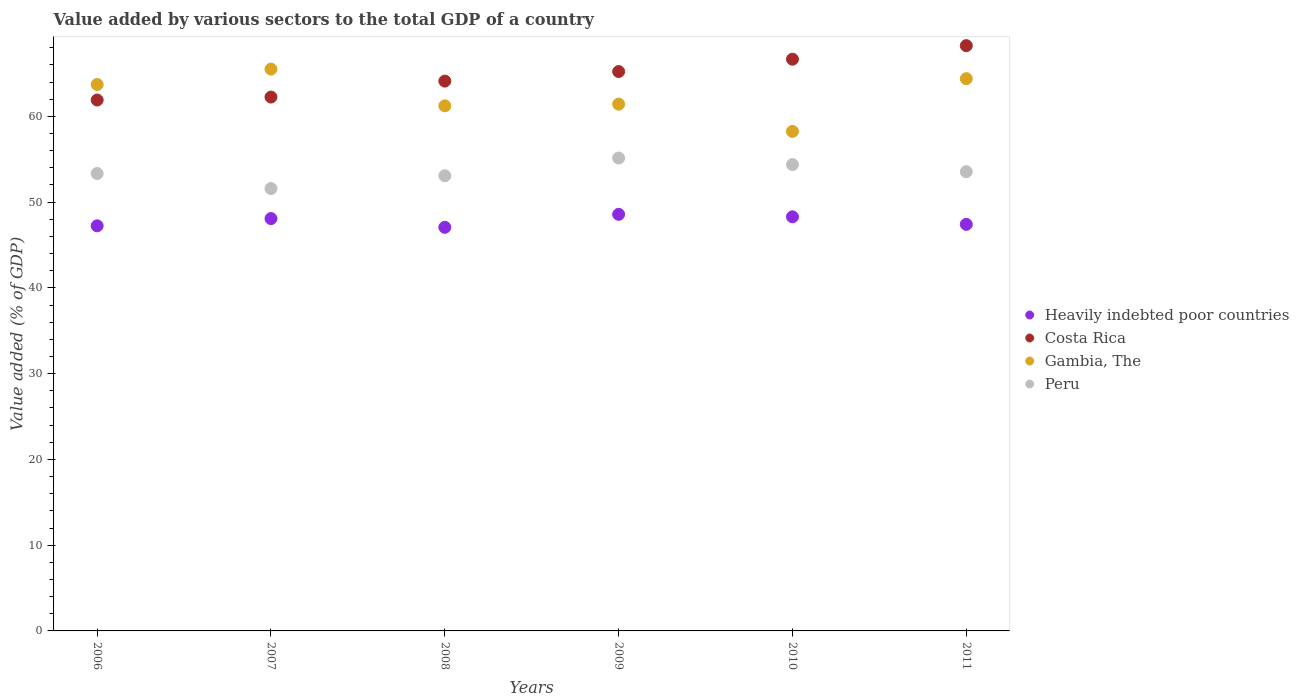Is the number of dotlines equal to the number of legend labels?
Offer a terse response. Yes. What is the value added by various sectors to the total GDP in Gambia, The in 2007?
Your answer should be very brief. 65.51. Across all years, what is the maximum value added by various sectors to the total GDP in Gambia, The?
Your response must be concise. 65.51. Across all years, what is the minimum value added by various sectors to the total GDP in Gambia, The?
Keep it short and to the point. 58.25. In which year was the value added by various sectors to the total GDP in Heavily indebted poor countries minimum?
Your response must be concise. 2008. What is the total value added by various sectors to the total GDP in Heavily indebted poor countries in the graph?
Give a very brief answer. 286.65. What is the difference between the value added by various sectors to the total GDP in Heavily indebted poor countries in 2006 and that in 2011?
Your answer should be compact. -0.17. What is the difference between the value added by various sectors to the total GDP in Gambia, The in 2010 and the value added by various sectors to the total GDP in Costa Rica in 2009?
Give a very brief answer. -6.98. What is the average value added by various sectors to the total GDP in Gambia, The per year?
Your answer should be very brief. 62.42. In the year 2009, what is the difference between the value added by various sectors to the total GDP in Heavily indebted poor countries and value added by various sectors to the total GDP in Costa Rica?
Provide a short and direct response. -16.65. In how many years, is the value added by various sectors to the total GDP in Heavily indebted poor countries greater than 16 %?
Offer a terse response. 6. What is the ratio of the value added by various sectors to the total GDP in Heavily indebted poor countries in 2006 to that in 2008?
Provide a succinct answer. 1. Is the value added by various sectors to the total GDP in Peru in 2009 less than that in 2010?
Keep it short and to the point. No. What is the difference between the highest and the second highest value added by various sectors to the total GDP in Gambia, The?
Ensure brevity in your answer.  1.12. What is the difference between the highest and the lowest value added by various sectors to the total GDP in Gambia, The?
Provide a succinct answer. 7.27. In how many years, is the value added by various sectors to the total GDP in Peru greater than the average value added by various sectors to the total GDP in Peru taken over all years?
Give a very brief answer. 3. Is the value added by various sectors to the total GDP in Gambia, The strictly less than the value added by various sectors to the total GDP in Peru over the years?
Your answer should be very brief. No. How many dotlines are there?
Give a very brief answer. 4. How many years are there in the graph?
Your answer should be very brief. 6. Does the graph contain any zero values?
Your answer should be very brief. No. Where does the legend appear in the graph?
Make the answer very short. Center right. How many legend labels are there?
Provide a short and direct response. 4. What is the title of the graph?
Offer a terse response. Value added by various sectors to the total GDP of a country. What is the label or title of the Y-axis?
Your response must be concise. Value added (% of GDP). What is the Value added (% of GDP) of Heavily indebted poor countries in 2006?
Provide a succinct answer. 47.24. What is the Value added (% of GDP) of Costa Rica in 2006?
Your answer should be compact. 61.9. What is the Value added (% of GDP) in Gambia, The in 2006?
Your answer should be compact. 63.71. What is the Value added (% of GDP) in Peru in 2006?
Offer a very short reply. 53.34. What is the Value added (% of GDP) in Heavily indebted poor countries in 2007?
Provide a short and direct response. 48.08. What is the Value added (% of GDP) of Costa Rica in 2007?
Offer a terse response. 62.25. What is the Value added (% of GDP) in Gambia, The in 2007?
Offer a terse response. 65.51. What is the Value added (% of GDP) of Peru in 2007?
Offer a very short reply. 51.58. What is the Value added (% of GDP) in Heavily indebted poor countries in 2008?
Provide a succinct answer. 47.06. What is the Value added (% of GDP) of Costa Rica in 2008?
Give a very brief answer. 64.11. What is the Value added (% of GDP) of Gambia, The in 2008?
Keep it short and to the point. 61.23. What is the Value added (% of GDP) of Peru in 2008?
Provide a succinct answer. 53.07. What is the Value added (% of GDP) in Heavily indebted poor countries in 2009?
Your answer should be very brief. 48.58. What is the Value added (% of GDP) of Costa Rica in 2009?
Provide a short and direct response. 65.23. What is the Value added (% of GDP) in Gambia, The in 2009?
Make the answer very short. 61.43. What is the Value added (% of GDP) of Peru in 2009?
Offer a very short reply. 55.14. What is the Value added (% of GDP) in Heavily indebted poor countries in 2010?
Give a very brief answer. 48.29. What is the Value added (% of GDP) in Costa Rica in 2010?
Provide a succinct answer. 66.66. What is the Value added (% of GDP) of Gambia, The in 2010?
Give a very brief answer. 58.25. What is the Value added (% of GDP) in Peru in 2010?
Your answer should be compact. 54.38. What is the Value added (% of GDP) in Heavily indebted poor countries in 2011?
Keep it short and to the point. 47.41. What is the Value added (% of GDP) of Costa Rica in 2011?
Your answer should be compact. 68.24. What is the Value added (% of GDP) in Gambia, The in 2011?
Ensure brevity in your answer.  64.39. What is the Value added (% of GDP) in Peru in 2011?
Keep it short and to the point. 53.55. Across all years, what is the maximum Value added (% of GDP) in Heavily indebted poor countries?
Give a very brief answer. 48.58. Across all years, what is the maximum Value added (% of GDP) of Costa Rica?
Provide a succinct answer. 68.24. Across all years, what is the maximum Value added (% of GDP) of Gambia, The?
Make the answer very short. 65.51. Across all years, what is the maximum Value added (% of GDP) in Peru?
Provide a short and direct response. 55.14. Across all years, what is the minimum Value added (% of GDP) of Heavily indebted poor countries?
Give a very brief answer. 47.06. Across all years, what is the minimum Value added (% of GDP) of Costa Rica?
Keep it short and to the point. 61.9. Across all years, what is the minimum Value added (% of GDP) of Gambia, The?
Your answer should be compact. 58.25. Across all years, what is the minimum Value added (% of GDP) in Peru?
Give a very brief answer. 51.58. What is the total Value added (% of GDP) in Heavily indebted poor countries in the graph?
Keep it short and to the point. 286.65. What is the total Value added (% of GDP) in Costa Rica in the graph?
Offer a very short reply. 388.4. What is the total Value added (% of GDP) of Gambia, The in the graph?
Offer a very short reply. 374.52. What is the total Value added (% of GDP) in Peru in the graph?
Offer a very short reply. 321.05. What is the difference between the Value added (% of GDP) in Heavily indebted poor countries in 2006 and that in 2007?
Keep it short and to the point. -0.84. What is the difference between the Value added (% of GDP) of Costa Rica in 2006 and that in 2007?
Your answer should be very brief. -0.35. What is the difference between the Value added (% of GDP) of Gambia, The in 2006 and that in 2007?
Make the answer very short. -1.8. What is the difference between the Value added (% of GDP) in Peru in 2006 and that in 2007?
Give a very brief answer. 1.76. What is the difference between the Value added (% of GDP) of Heavily indebted poor countries in 2006 and that in 2008?
Ensure brevity in your answer.  0.18. What is the difference between the Value added (% of GDP) in Costa Rica in 2006 and that in 2008?
Make the answer very short. -2.21. What is the difference between the Value added (% of GDP) in Gambia, The in 2006 and that in 2008?
Make the answer very short. 2.49. What is the difference between the Value added (% of GDP) in Peru in 2006 and that in 2008?
Your response must be concise. 0.26. What is the difference between the Value added (% of GDP) in Heavily indebted poor countries in 2006 and that in 2009?
Ensure brevity in your answer.  -1.34. What is the difference between the Value added (% of GDP) in Costa Rica in 2006 and that in 2009?
Your response must be concise. -3.32. What is the difference between the Value added (% of GDP) in Gambia, The in 2006 and that in 2009?
Provide a succinct answer. 2.29. What is the difference between the Value added (% of GDP) of Peru in 2006 and that in 2009?
Provide a succinct answer. -1.8. What is the difference between the Value added (% of GDP) in Heavily indebted poor countries in 2006 and that in 2010?
Give a very brief answer. -1.05. What is the difference between the Value added (% of GDP) in Costa Rica in 2006 and that in 2010?
Provide a short and direct response. -4.76. What is the difference between the Value added (% of GDP) of Gambia, The in 2006 and that in 2010?
Offer a terse response. 5.47. What is the difference between the Value added (% of GDP) in Peru in 2006 and that in 2010?
Your answer should be very brief. -1.04. What is the difference between the Value added (% of GDP) of Heavily indebted poor countries in 2006 and that in 2011?
Your response must be concise. -0.17. What is the difference between the Value added (% of GDP) of Costa Rica in 2006 and that in 2011?
Make the answer very short. -6.34. What is the difference between the Value added (% of GDP) of Gambia, The in 2006 and that in 2011?
Keep it short and to the point. -0.68. What is the difference between the Value added (% of GDP) in Peru in 2006 and that in 2011?
Provide a short and direct response. -0.21. What is the difference between the Value added (% of GDP) in Heavily indebted poor countries in 2007 and that in 2008?
Provide a short and direct response. 1.02. What is the difference between the Value added (% of GDP) in Costa Rica in 2007 and that in 2008?
Offer a terse response. -1.86. What is the difference between the Value added (% of GDP) in Gambia, The in 2007 and that in 2008?
Your answer should be compact. 4.29. What is the difference between the Value added (% of GDP) in Peru in 2007 and that in 2008?
Ensure brevity in your answer.  -1.49. What is the difference between the Value added (% of GDP) of Heavily indebted poor countries in 2007 and that in 2009?
Offer a terse response. -0.5. What is the difference between the Value added (% of GDP) of Costa Rica in 2007 and that in 2009?
Your response must be concise. -2.98. What is the difference between the Value added (% of GDP) of Gambia, The in 2007 and that in 2009?
Give a very brief answer. 4.09. What is the difference between the Value added (% of GDP) of Peru in 2007 and that in 2009?
Offer a terse response. -3.56. What is the difference between the Value added (% of GDP) in Heavily indebted poor countries in 2007 and that in 2010?
Ensure brevity in your answer.  -0.2. What is the difference between the Value added (% of GDP) in Costa Rica in 2007 and that in 2010?
Give a very brief answer. -4.41. What is the difference between the Value added (% of GDP) of Gambia, The in 2007 and that in 2010?
Give a very brief answer. 7.27. What is the difference between the Value added (% of GDP) of Peru in 2007 and that in 2010?
Make the answer very short. -2.8. What is the difference between the Value added (% of GDP) of Heavily indebted poor countries in 2007 and that in 2011?
Keep it short and to the point. 0.68. What is the difference between the Value added (% of GDP) in Costa Rica in 2007 and that in 2011?
Ensure brevity in your answer.  -5.99. What is the difference between the Value added (% of GDP) of Gambia, The in 2007 and that in 2011?
Offer a terse response. 1.12. What is the difference between the Value added (% of GDP) in Peru in 2007 and that in 2011?
Provide a succinct answer. -1.96. What is the difference between the Value added (% of GDP) of Heavily indebted poor countries in 2008 and that in 2009?
Make the answer very short. -1.52. What is the difference between the Value added (% of GDP) in Costa Rica in 2008 and that in 2009?
Your answer should be compact. -1.12. What is the difference between the Value added (% of GDP) in Gambia, The in 2008 and that in 2009?
Provide a short and direct response. -0.2. What is the difference between the Value added (% of GDP) of Peru in 2008 and that in 2009?
Your answer should be very brief. -2.06. What is the difference between the Value added (% of GDP) of Heavily indebted poor countries in 2008 and that in 2010?
Your response must be concise. -1.23. What is the difference between the Value added (% of GDP) in Costa Rica in 2008 and that in 2010?
Make the answer very short. -2.55. What is the difference between the Value added (% of GDP) of Gambia, The in 2008 and that in 2010?
Your answer should be compact. 2.98. What is the difference between the Value added (% of GDP) of Peru in 2008 and that in 2010?
Offer a very short reply. -1.3. What is the difference between the Value added (% of GDP) in Heavily indebted poor countries in 2008 and that in 2011?
Make the answer very short. -0.35. What is the difference between the Value added (% of GDP) in Costa Rica in 2008 and that in 2011?
Keep it short and to the point. -4.13. What is the difference between the Value added (% of GDP) in Gambia, The in 2008 and that in 2011?
Make the answer very short. -3.17. What is the difference between the Value added (% of GDP) of Peru in 2008 and that in 2011?
Keep it short and to the point. -0.47. What is the difference between the Value added (% of GDP) of Heavily indebted poor countries in 2009 and that in 2010?
Offer a very short reply. 0.29. What is the difference between the Value added (% of GDP) of Costa Rica in 2009 and that in 2010?
Make the answer very short. -1.44. What is the difference between the Value added (% of GDP) in Gambia, The in 2009 and that in 2010?
Offer a terse response. 3.18. What is the difference between the Value added (% of GDP) in Peru in 2009 and that in 2010?
Your answer should be compact. 0.76. What is the difference between the Value added (% of GDP) in Heavily indebted poor countries in 2009 and that in 2011?
Make the answer very short. 1.17. What is the difference between the Value added (% of GDP) in Costa Rica in 2009 and that in 2011?
Ensure brevity in your answer.  -3.02. What is the difference between the Value added (% of GDP) of Gambia, The in 2009 and that in 2011?
Provide a succinct answer. -2.97. What is the difference between the Value added (% of GDP) in Peru in 2009 and that in 2011?
Keep it short and to the point. 1.59. What is the difference between the Value added (% of GDP) of Heavily indebted poor countries in 2010 and that in 2011?
Provide a short and direct response. 0.88. What is the difference between the Value added (% of GDP) in Costa Rica in 2010 and that in 2011?
Give a very brief answer. -1.58. What is the difference between the Value added (% of GDP) in Gambia, The in 2010 and that in 2011?
Make the answer very short. -6.15. What is the difference between the Value added (% of GDP) in Peru in 2010 and that in 2011?
Keep it short and to the point. 0.83. What is the difference between the Value added (% of GDP) of Heavily indebted poor countries in 2006 and the Value added (% of GDP) of Costa Rica in 2007?
Offer a terse response. -15.01. What is the difference between the Value added (% of GDP) in Heavily indebted poor countries in 2006 and the Value added (% of GDP) in Gambia, The in 2007?
Your answer should be very brief. -18.28. What is the difference between the Value added (% of GDP) in Heavily indebted poor countries in 2006 and the Value added (% of GDP) in Peru in 2007?
Ensure brevity in your answer.  -4.34. What is the difference between the Value added (% of GDP) in Costa Rica in 2006 and the Value added (% of GDP) in Gambia, The in 2007?
Your answer should be compact. -3.61. What is the difference between the Value added (% of GDP) of Costa Rica in 2006 and the Value added (% of GDP) of Peru in 2007?
Make the answer very short. 10.32. What is the difference between the Value added (% of GDP) in Gambia, The in 2006 and the Value added (% of GDP) in Peru in 2007?
Your answer should be compact. 12.13. What is the difference between the Value added (% of GDP) in Heavily indebted poor countries in 2006 and the Value added (% of GDP) in Costa Rica in 2008?
Provide a short and direct response. -16.88. What is the difference between the Value added (% of GDP) in Heavily indebted poor countries in 2006 and the Value added (% of GDP) in Gambia, The in 2008?
Keep it short and to the point. -13.99. What is the difference between the Value added (% of GDP) in Heavily indebted poor countries in 2006 and the Value added (% of GDP) in Peru in 2008?
Your answer should be very brief. -5.84. What is the difference between the Value added (% of GDP) of Costa Rica in 2006 and the Value added (% of GDP) of Gambia, The in 2008?
Your answer should be compact. 0.68. What is the difference between the Value added (% of GDP) in Costa Rica in 2006 and the Value added (% of GDP) in Peru in 2008?
Keep it short and to the point. 8.83. What is the difference between the Value added (% of GDP) of Gambia, The in 2006 and the Value added (% of GDP) of Peru in 2008?
Your answer should be very brief. 10.64. What is the difference between the Value added (% of GDP) of Heavily indebted poor countries in 2006 and the Value added (% of GDP) of Costa Rica in 2009?
Offer a very short reply. -17.99. What is the difference between the Value added (% of GDP) of Heavily indebted poor countries in 2006 and the Value added (% of GDP) of Gambia, The in 2009?
Give a very brief answer. -14.19. What is the difference between the Value added (% of GDP) of Heavily indebted poor countries in 2006 and the Value added (% of GDP) of Peru in 2009?
Offer a very short reply. -7.9. What is the difference between the Value added (% of GDP) in Costa Rica in 2006 and the Value added (% of GDP) in Gambia, The in 2009?
Provide a short and direct response. 0.48. What is the difference between the Value added (% of GDP) in Costa Rica in 2006 and the Value added (% of GDP) in Peru in 2009?
Your response must be concise. 6.77. What is the difference between the Value added (% of GDP) in Gambia, The in 2006 and the Value added (% of GDP) in Peru in 2009?
Ensure brevity in your answer.  8.58. What is the difference between the Value added (% of GDP) of Heavily indebted poor countries in 2006 and the Value added (% of GDP) of Costa Rica in 2010?
Provide a succinct answer. -19.43. What is the difference between the Value added (% of GDP) of Heavily indebted poor countries in 2006 and the Value added (% of GDP) of Gambia, The in 2010?
Provide a short and direct response. -11.01. What is the difference between the Value added (% of GDP) in Heavily indebted poor countries in 2006 and the Value added (% of GDP) in Peru in 2010?
Ensure brevity in your answer.  -7.14. What is the difference between the Value added (% of GDP) in Costa Rica in 2006 and the Value added (% of GDP) in Gambia, The in 2010?
Offer a terse response. 3.66. What is the difference between the Value added (% of GDP) of Costa Rica in 2006 and the Value added (% of GDP) of Peru in 2010?
Provide a short and direct response. 7.53. What is the difference between the Value added (% of GDP) of Gambia, The in 2006 and the Value added (% of GDP) of Peru in 2010?
Provide a succinct answer. 9.34. What is the difference between the Value added (% of GDP) in Heavily indebted poor countries in 2006 and the Value added (% of GDP) in Costa Rica in 2011?
Keep it short and to the point. -21.01. What is the difference between the Value added (% of GDP) of Heavily indebted poor countries in 2006 and the Value added (% of GDP) of Gambia, The in 2011?
Offer a very short reply. -17.16. What is the difference between the Value added (% of GDP) of Heavily indebted poor countries in 2006 and the Value added (% of GDP) of Peru in 2011?
Offer a very short reply. -6.31. What is the difference between the Value added (% of GDP) in Costa Rica in 2006 and the Value added (% of GDP) in Gambia, The in 2011?
Offer a terse response. -2.49. What is the difference between the Value added (% of GDP) of Costa Rica in 2006 and the Value added (% of GDP) of Peru in 2011?
Provide a succinct answer. 8.36. What is the difference between the Value added (% of GDP) of Gambia, The in 2006 and the Value added (% of GDP) of Peru in 2011?
Offer a terse response. 10.17. What is the difference between the Value added (% of GDP) in Heavily indebted poor countries in 2007 and the Value added (% of GDP) in Costa Rica in 2008?
Your answer should be very brief. -16.03. What is the difference between the Value added (% of GDP) in Heavily indebted poor countries in 2007 and the Value added (% of GDP) in Gambia, The in 2008?
Your response must be concise. -13.14. What is the difference between the Value added (% of GDP) of Heavily indebted poor countries in 2007 and the Value added (% of GDP) of Peru in 2008?
Make the answer very short. -4.99. What is the difference between the Value added (% of GDP) in Costa Rica in 2007 and the Value added (% of GDP) in Gambia, The in 2008?
Ensure brevity in your answer.  1.02. What is the difference between the Value added (% of GDP) of Costa Rica in 2007 and the Value added (% of GDP) of Peru in 2008?
Give a very brief answer. 9.18. What is the difference between the Value added (% of GDP) in Gambia, The in 2007 and the Value added (% of GDP) in Peru in 2008?
Provide a short and direct response. 12.44. What is the difference between the Value added (% of GDP) in Heavily indebted poor countries in 2007 and the Value added (% of GDP) in Costa Rica in 2009?
Offer a terse response. -17.15. What is the difference between the Value added (% of GDP) of Heavily indebted poor countries in 2007 and the Value added (% of GDP) of Gambia, The in 2009?
Offer a very short reply. -13.34. What is the difference between the Value added (% of GDP) of Heavily indebted poor countries in 2007 and the Value added (% of GDP) of Peru in 2009?
Your response must be concise. -7.06. What is the difference between the Value added (% of GDP) of Costa Rica in 2007 and the Value added (% of GDP) of Gambia, The in 2009?
Keep it short and to the point. 0.82. What is the difference between the Value added (% of GDP) of Costa Rica in 2007 and the Value added (% of GDP) of Peru in 2009?
Offer a very short reply. 7.11. What is the difference between the Value added (% of GDP) in Gambia, The in 2007 and the Value added (% of GDP) in Peru in 2009?
Ensure brevity in your answer.  10.38. What is the difference between the Value added (% of GDP) in Heavily indebted poor countries in 2007 and the Value added (% of GDP) in Costa Rica in 2010?
Your answer should be very brief. -18.58. What is the difference between the Value added (% of GDP) of Heavily indebted poor countries in 2007 and the Value added (% of GDP) of Gambia, The in 2010?
Your answer should be compact. -10.16. What is the difference between the Value added (% of GDP) of Heavily indebted poor countries in 2007 and the Value added (% of GDP) of Peru in 2010?
Keep it short and to the point. -6.3. What is the difference between the Value added (% of GDP) of Costa Rica in 2007 and the Value added (% of GDP) of Gambia, The in 2010?
Ensure brevity in your answer.  4. What is the difference between the Value added (% of GDP) in Costa Rica in 2007 and the Value added (% of GDP) in Peru in 2010?
Provide a short and direct response. 7.87. What is the difference between the Value added (% of GDP) of Gambia, The in 2007 and the Value added (% of GDP) of Peru in 2010?
Ensure brevity in your answer.  11.14. What is the difference between the Value added (% of GDP) in Heavily indebted poor countries in 2007 and the Value added (% of GDP) in Costa Rica in 2011?
Offer a very short reply. -20.16. What is the difference between the Value added (% of GDP) of Heavily indebted poor countries in 2007 and the Value added (% of GDP) of Gambia, The in 2011?
Offer a terse response. -16.31. What is the difference between the Value added (% of GDP) of Heavily indebted poor countries in 2007 and the Value added (% of GDP) of Peru in 2011?
Keep it short and to the point. -5.46. What is the difference between the Value added (% of GDP) in Costa Rica in 2007 and the Value added (% of GDP) in Gambia, The in 2011?
Offer a terse response. -2.14. What is the difference between the Value added (% of GDP) of Costa Rica in 2007 and the Value added (% of GDP) of Peru in 2011?
Provide a short and direct response. 8.7. What is the difference between the Value added (% of GDP) in Gambia, The in 2007 and the Value added (% of GDP) in Peru in 2011?
Keep it short and to the point. 11.97. What is the difference between the Value added (% of GDP) in Heavily indebted poor countries in 2008 and the Value added (% of GDP) in Costa Rica in 2009?
Your response must be concise. -18.17. What is the difference between the Value added (% of GDP) in Heavily indebted poor countries in 2008 and the Value added (% of GDP) in Gambia, The in 2009?
Give a very brief answer. -14.37. What is the difference between the Value added (% of GDP) of Heavily indebted poor countries in 2008 and the Value added (% of GDP) of Peru in 2009?
Keep it short and to the point. -8.08. What is the difference between the Value added (% of GDP) of Costa Rica in 2008 and the Value added (% of GDP) of Gambia, The in 2009?
Your response must be concise. 2.69. What is the difference between the Value added (% of GDP) in Costa Rica in 2008 and the Value added (% of GDP) in Peru in 2009?
Keep it short and to the point. 8.97. What is the difference between the Value added (% of GDP) of Gambia, The in 2008 and the Value added (% of GDP) of Peru in 2009?
Offer a very short reply. 6.09. What is the difference between the Value added (% of GDP) in Heavily indebted poor countries in 2008 and the Value added (% of GDP) in Costa Rica in 2010?
Your response must be concise. -19.6. What is the difference between the Value added (% of GDP) in Heavily indebted poor countries in 2008 and the Value added (% of GDP) in Gambia, The in 2010?
Offer a very short reply. -11.19. What is the difference between the Value added (% of GDP) of Heavily indebted poor countries in 2008 and the Value added (% of GDP) of Peru in 2010?
Keep it short and to the point. -7.32. What is the difference between the Value added (% of GDP) in Costa Rica in 2008 and the Value added (% of GDP) in Gambia, The in 2010?
Keep it short and to the point. 5.87. What is the difference between the Value added (% of GDP) in Costa Rica in 2008 and the Value added (% of GDP) in Peru in 2010?
Provide a short and direct response. 9.73. What is the difference between the Value added (% of GDP) in Gambia, The in 2008 and the Value added (% of GDP) in Peru in 2010?
Your answer should be compact. 6.85. What is the difference between the Value added (% of GDP) in Heavily indebted poor countries in 2008 and the Value added (% of GDP) in Costa Rica in 2011?
Provide a succinct answer. -21.18. What is the difference between the Value added (% of GDP) in Heavily indebted poor countries in 2008 and the Value added (% of GDP) in Gambia, The in 2011?
Give a very brief answer. -17.33. What is the difference between the Value added (% of GDP) in Heavily indebted poor countries in 2008 and the Value added (% of GDP) in Peru in 2011?
Give a very brief answer. -6.48. What is the difference between the Value added (% of GDP) in Costa Rica in 2008 and the Value added (% of GDP) in Gambia, The in 2011?
Provide a succinct answer. -0.28. What is the difference between the Value added (% of GDP) in Costa Rica in 2008 and the Value added (% of GDP) in Peru in 2011?
Keep it short and to the point. 10.57. What is the difference between the Value added (% of GDP) of Gambia, The in 2008 and the Value added (% of GDP) of Peru in 2011?
Keep it short and to the point. 7.68. What is the difference between the Value added (% of GDP) of Heavily indebted poor countries in 2009 and the Value added (% of GDP) of Costa Rica in 2010?
Keep it short and to the point. -18.09. What is the difference between the Value added (% of GDP) in Heavily indebted poor countries in 2009 and the Value added (% of GDP) in Gambia, The in 2010?
Ensure brevity in your answer.  -9.67. What is the difference between the Value added (% of GDP) in Heavily indebted poor countries in 2009 and the Value added (% of GDP) in Peru in 2010?
Your response must be concise. -5.8. What is the difference between the Value added (% of GDP) in Costa Rica in 2009 and the Value added (% of GDP) in Gambia, The in 2010?
Offer a terse response. 6.98. What is the difference between the Value added (% of GDP) in Costa Rica in 2009 and the Value added (% of GDP) in Peru in 2010?
Offer a terse response. 10.85. What is the difference between the Value added (% of GDP) in Gambia, The in 2009 and the Value added (% of GDP) in Peru in 2010?
Your answer should be compact. 7.05. What is the difference between the Value added (% of GDP) of Heavily indebted poor countries in 2009 and the Value added (% of GDP) of Costa Rica in 2011?
Your answer should be very brief. -19.67. What is the difference between the Value added (% of GDP) of Heavily indebted poor countries in 2009 and the Value added (% of GDP) of Gambia, The in 2011?
Make the answer very short. -15.82. What is the difference between the Value added (% of GDP) in Heavily indebted poor countries in 2009 and the Value added (% of GDP) in Peru in 2011?
Offer a terse response. -4.97. What is the difference between the Value added (% of GDP) of Costa Rica in 2009 and the Value added (% of GDP) of Gambia, The in 2011?
Your response must be concise. 0.83. What is the difference between the Value added (% of GDP) in Costa Rica in 2009 and the Value added (% of GDP) in Peru in 2011?
Give a very brief answer. 11.68. What is the difference between the Value added (% of GDP) in Gambia, The in 2009 and the Value added (% of GDP) in Peru in 2011?
Your answer should be very brief. 7.88. What is the difference between the Value added (% of GDP) of Heavily indebted poor countries in 2010 and the Value added (% of GDP) of Costa Rica in 2011?
Ensure brevity in your answer.  -19.96. What is the difference between the Value added (% of GDP) in Heavily indebted poor countries in 2010 and the Value added (% of GDP) in Gambia, The in 2011?
Offer a very short reply. -16.11. What is the difference between the Value added (% of GDP) of Heavily indebted poor countries in 2010 and the Value added (% of GDP) of Peru in 2011?
Your response must be concise. -5.26. What is the difference between the Value added (% of GDP) of Costa Rica in 2010 and the Value added (% of GDP) of Gambia, The in 2011?
Offer a terse response. 2.27. What is the difference between the Value added (% of GDP) of Costa Rica in 2010 and the Value added (% of GDP) of Peru in 2011?
Ensure brevity in your answer.  13.12. What is the difference between the Value added (% of GDP) in Gambia, The in 2010 and the Value added (% of GDP) in Peru in 2011?
Offer a terse response. 4.7. What is the average Value added (% of GDP) of Heavily indebted poor countries per year?
Keep it short and to the point. 47.78. What is the average Value added (% of GDP) in Costa Rica per year?
Ensure brevity in your answer.  64.73. What is the average Value added (% of GDP) in Gambia, The per year?
Your answer should be very brief. 62.42. What is the average Value added (% of GDP) of Peru per year?
Give a very brief answer. 53.51. In the year 2006, what is the difference between the Value added (% of GDP) of Heavily indebted poor countries and Value added (% of GDP) of Costa Rica?
Your answer should be very brief. -14.67. In the year 2006, what is the difference between the Value added (% of GDP) in Heavily indebted poor countries and Value added (% of GDP) in Gambia, The?
Make the answer very short. -16.48. In the year 2006, what is the difference between the Value added (% of GDP) of Heavily indebted poor countries and Value added (% of GDP) of Peru?
Your answer should be very brief. -6.1. In the year 2006, what is the difference between the Value added (% of GDP) in Costa Rica and Value added (% of GDP) in Gambia, The?
Ensure brevity in your answer.  -1.81. In the year 2006, what is the difference between the Value added (% of GDP) in Costa Rica and Value added (% of GDP) in Peru?
Your answer should be very brief. 8.57. In the year 2006, what is the difference between the Value added (% of GDP) of Gambia, The and Value added (% of GDP) of Peru?
Make the answer very short. 10.38. In the year 2007, what is the difference between the Value added (% of GDP) in Heavily indebted poor countries and Value added (% of GDP) in Costa Rica?
Give a very brief answer. -14.17. In the year 2007, what is the difference between the Value added (% of GDP) of Heavily indebted poor countries and Value added (% of GDP) of Gambia, The?
Make the answer very short. -17.43. In the year 2007, what is the difference between the Value added (% of GDP) in Heavily indebted poor countries and Value added (% of GDP) in Peru?
Offer a terse response. -3.5. In the year 2007, what is the difference between the Value added (% of GDP) in Costa Rica and Value added (% of GDP) in Gambia, The?
Offer a terse response. -3.26. In the year 2007, what is the difference between the Value added (% of GDP) of Costa Rica and Value added (% of GDP) of Peru?
Offer a very short reply. 10.67. In the year 2007, what is the difference between the Value added (% of GDP) in Gambia, The and Value added (% of GDP) in Peru?
Provide a short and direct response. 13.93. In the year 2008, what is the difference between the Value added (% of GDP) in Heavily indebted poor countries and Value added (% of GDP) in Costa Rica?
Provide a short and direct response. -17.05. In the year 2008, what is the difference between the Value added (% of GDP) in Heavily indebted poor countries and Value added (% of GDP) in Gambia, The?
Keep it short and to the point. -14.17. In the year 2008, what is the difference between the Value added (% of GDP) of Heavily indebted poor countries and Value added (% of GDP) of Peru?
Your answer should be compact. -6.01. In the year 2008, what is the difference between the Value added (% of GDP) of Costa Rica and Value added (% of GDP) of Gambia, The?
Your answer should be very brief. 2.89. In the year 2008, what is the difference between the Value added (% of GDP) of Costa Rica and Value added (% of GDP) of Peru?
Offer a very short reply. 11.04. In the year 2008, what is the difference between the Value added (% of GDP) in Gambia, The and Value added (% of GDP) in Peru?
Make the answer very short. 8.15. In the year 2009, what is the difference between the Value added (% of GDP) of Heavily indebted poor countries and Value added (% of GDP) of Costa Rica?
Your response must be concise. -16.65. In the year 2009, what is the difference between the Value added (% of GDP) in Heavily indebted poor countries and Value added (% of GDP) in Gambia, The?
Make the answer very short. -12.85. In the year 2009, what is the difference between the Value added (% of GDP) of Heavily indebted poor countries and Value added (% of GDP) of Peru?
Your answer should be very brief. -6.56. In the year 2009, what is the difference between the Value added (% of GDP) in Costa Rica and Value added (% of GDP) in Gambia, The?
Your response must be concise. 3.8. In the year 2009, what is the difference between the Value added (% of GDP) of Costa Rica and Value added (% of GDP) of Peru?
Provide a succinct answer. 10.09. In the year 2009, what is the difference between the Value added (% of GDP) of Gambia, The and Value added (% of GDP) of Peru?
Make the answer very short. 6.29. In the year 2010, what is the difference between the Value added (% of GDP) in Heavily indebted poor countries and Value added (% of GDP) in Costa Rica?
Your answer should be very brief. -18.38. In the year 2010, what is the difference between the Value added (% of GDP) in Heavily indebted poor countries and Value added (% of GDP) in Gambia, The?
Give a very brief answer. -9.96. In the year 2010, what is the difference between the Value added (% of GDP) in Heavily indebted poor countries and Value added (% of GDP) in Peru?
Keep it short and to the point. -6.09. In the year 2010, what is the difference between the Value added (% of GDP) of Costa Rica and Value added (% of GDP) of Gambia, The?
Offer a very short reply. 8.42. In the year 2010, what is the difference between the Value added (% of GDP) in Costa Rica and Value added (% of GDP) in Peru?
Provide a short and direct response. 12.29. In the year 2010, what is the difference between the Value added (% of GDP) of Gambia, The and Value added (% of GDP) of Peru?
Make the answer very short. 3.87. In the year 2011, what is the difference between the Value added (% of GDP) in Heavily indebted poor countries and Value added (% of GDP) in Costa Rica?
Give a very brief answer. -20.84. In the year 2011, what is the difference between the Value added (% of GDP) in Heavily indebted poor countries and Value added (% of GDP) in Gambia, The?
Your answer should be very brief. -16.99. In the year 2011, what is the difference between the Value added (% of GDP) in Heavily indebted poor countries and Value added (% of GDP) in Peru?
Offer a terse response. -6.14. In the year 2011, what is the difference between the Value added (% of GDP) of Costa Rica and Value added (% of GDP) of Gambia, The?
Ensure brevity in your answer.  3.85. In the year 2011, what is the difference between the Value added (% of GDP) of Costa Rica and Value added (% of GDP) of Peru?
Your answer should be compact. 14.7. In the year 2011, what is the difference between the Value added (% of GDP) of Gambia, The and Value added (% of GDP) of Peru?
Your answer should be very brief. 10.85. What is the ratio of the Value added (% of GDP) of Heavily indebted poor countries in 2006 to that in 2007?
Ensure brevity in your answer.  0.98. What is the ratio of the Value added (% of GDP) in Gambia, The in 2006 to that in 2007?
Your answer should be very brief. 0.97. What is the ratio of the Value added (% of GDP) of Peru in 2006 to that in 2007?
Give a very brief answer. 1.03. What is the ratio of the Value added (% of GDP) in Heavily indebted poor countries in 2006 to that in 2008?
Your response must be concise. 1. What is the ratio of the Value added (% of GDP) of Costa Rica in 2006 to that in 2008?
Your answer should be compact. 0.97. What is the ratio of the Value added (% of GDP) in Gambia, The in 2006 to that in 2008?
Make the answer very short. 1.04. What is the ratio of the Value added (% of GDP) of Heavily indebted poor countries in 2006 to that in 2009?
Give a very brief answer. 0.97. What is the ratio of the Value added (% of GDP) of Costa Rica in 2006 to that in 2009?
Ensure brevity in your answer.  0.95. What is the ratio of the Value added (% of GDP) of Gambia, The in 2006 to that in 2009?
Offer a very short reply. 1.04. What is the ratio of the Value added (% of GDP) in Peru in 2006 to that in 2009?
Provide a short and direct response. 0.97. What is the ratio of the Value added (% of GDP) of Heavily indebted poor countries in 2006 to that in 2010?
Your answer should be compact. 0.98. What is the ratio of the Value added (% of GDP) of Costa Rica in 2006 to that in 2010?
Offer a terse response. 0.93. What is the ratio of the Value added (% of GDP) of Gambia, The in 2006 to that in 2010?
Give a very brief answer. 1.09. What is the ratio of the Value added (% of GDP) in Peru in 2006 to that in 2010?
Provide a succinct answer. 0.98. What is the ratio of the Value added (% of GDP) in Heavily indebted poor countries in 2006 to that in 2011?
Offer a terse response. 1. What is the ratio of the Value added (% of GDP) of Costa Rica in 2006 to that in 2011?
Give a very brief answer. 0.91. What is the ratio of the Value added (% of GDP) in Gambia, The in 2006 to that in 2011?
Offer a very short reply. 0.99. What is the ratio of the Value added (% of GDP) in Peru in 2006 to that in 2011?
Make the answer very short. 1. What is the ratio of the Value added (% of GDP) in Heavily indebted poor countries in 2007 to that in 2008?
Give a very brief answer. 1.02. What is the ratio of the Value added (% of GDP) in Costa Rica in 2007 to that in 2008?
Your response must be concise. 0.97. What is the ratio of the Value added (% of GDP) of Gambia, The in 2007 to that in 2008?
Your answer should be compact. 1.07. What is the ratio of the Value added (% of GDP) of Peru in 2007 to that in 2008?
Offer a terse response. 0.97. What is the ratio of the Value added (% of GDP) in Costa Rica in 2007 to that in 2009?
Offer a terse response. 0.95. What is the ratio of the Value added (% of GDP) in Gambia, The in 2007 to that in 2009?
Offer a terse response. 1.07. What is the ratio of the Value added (% of GDP) of Peru in 2007 to that in 2009?
Offer a very short reply. 0.94. What is the ratio of the Value added (% of GDP) of Heavily indebted poor countries in 2007 to that in 2010?
Your response must be concise. 1. What is the ratio of the Value added (% of GDP) in Costa Rica in 2007 to that in 2010?
Your answer should be very brief. 0.93. What is the ratio of the Value added (% of GDP) in Gambia, The in 2007 to that in 2010?
Make the answer very short. 1.12. What is the ratio of the Value added (% of GDP) of Peru in 2007 to that in 2010?
Provide a short and direct response. 0.95. What is the ratio of the Value added (% of GDP) in Heavily indebted poor countries in 2007 to that in 2011?
Keep it short and to the point. 1.01. What is the ratio of the Value added (% of GDP) in Costa Rica in 2007 to that in 2011?
Give a very brief answer. 0.91. What is the ratio of the Value added (% of GDP) in Gambia, The in 2007 to that in 2011?
Make the answer very short. 1.02. What is the ratio of the Value added (% of GDP) of Peru in 2007 to that in 2011?
Make the answer very short. 0.96. What is the ratio of the Value added (% of GDP) in Heavily indebted poor countries in 2008 to that in 2009?
Your answer should be very brief. 0.97. What is the ratio of the Value added (% of GDP) in Costa Rica in 2008 to that in 2009?
Provide a short and direct response. 0.98. What is the ratio of the Value added (% of GDP) in Gambia, The in 2008 to that in 2009?
Offer a terse response. 1. What is the ratio of the Value added (% of GDP) of Peru in 2008 to that in 2009?
Offer a terse response. 0.96. What is the ratio of the Value added (% of GDP) in Heavily indebted poor countries in 2008 to that in 2010?
Your answer should be compact. 0.97. What is the ratio of the Value added (% of GDP) in Costa Rica in 2008 to that in 2010?
Ensure brevity in your answer.  0.96. What is the ratio of the Value added (% of GDP) in Gambia, The in 2008 to that in 2010?
Provide a short and direct response. 1.05. What is the ratio of the Value added (% of GDP) in Peru in 2008 to that in 2010?
Offer a very short reply. 0.98. What is the ratio of the Value added (% of GDP) in Costa Rica in 2008 to that in 2011?
Provide a succinct answer. 0.94. What is the ratio of the Value added (% of GDP) in Gambia, The in 2008 to that in 2011?
Your answer should be very brief. 0.95. What is the ratio of the Value added (% of GDP) of Peru in 2008 to that in 2011?
Offer a very short reply. 0.99. What is the ratio of the Value added (% of GDP) in Costa Rica in 2009 to that in 2010?
Provide a succinct answer. 0.98. What is the ratio of the Value added (% of GDP) in Gambia, The in 2009 to that in 2010?
Make the answer very short. 1.05. What is the ratio of the Value added (% of GDP) of Heavily indebted poor countries in 2009 to that in 2011?
Keep it short and to the point. 1.02. What is the ratio of the Value added (% of GDP) of Costa Rica in 2009 to that in 2011?
Your answer should be compact. 0.96. What is the ratio of the Value added (% of GDP) of Gambia, The in 2009 to that in 2011?
Provide a succinct answer. 0.95. What is the ratio of the Value added (% of GDP) of Peru in 2009 to that in 2011?
Your response must be concise. 1.03. What is the ratio of the Value added (% of GDP) of Heavily indebted poor countries in 2010 to that in 2011?
Offer a terse response. 1.02. What is the ratio of the Value added (% of GDP) in Costa Rica in 2010 to that in 2011?
Give a very brief answer. 0.98. What is the ratio of the Value added (% of GDP) in Gambia, The in 2010 to that in 2011?
Offer a very short reply. 0.9. What is the ratio of the Value added (% of GDP) in Peru in 2010 to that in 2011?
Ensure brevity in your answer.  1.02. What is the difference between the highest and the second highest Value added (% of GDP) in Heavily indebted poor countries?
Give a very brief answer. 0.29. What is the difference between the highest and the second highest Value added (% of GDP) of Costa Rica?
Make the answer very short. 1.58. What is the difference between the highest and the second highest Value added (% of GDP) of Gambia, The?
Your response must be concise. 1.12. What is the difference between the highest and the second highest Value added (% of GDP) in Peru?
Offer a very short reply. 0.76. What is the difference between the highest and the lowest Value added (% of GDP) in Heavily indebted poor countries?
Your answer should be very brief. 1.52. What is the difference between the highest and the lowest Value added (% of GDP) of Costa Rica?
Provide a short and direct response. 6.34. What is the difference between the highest and the lowest Value added (% of GDP) in Gambia, The?
Provide a succinct answer. 7.27. What is the difference between the highest and the lowest Value added (% of GDP) in Peru?
Make the answer very short. 3.56. 